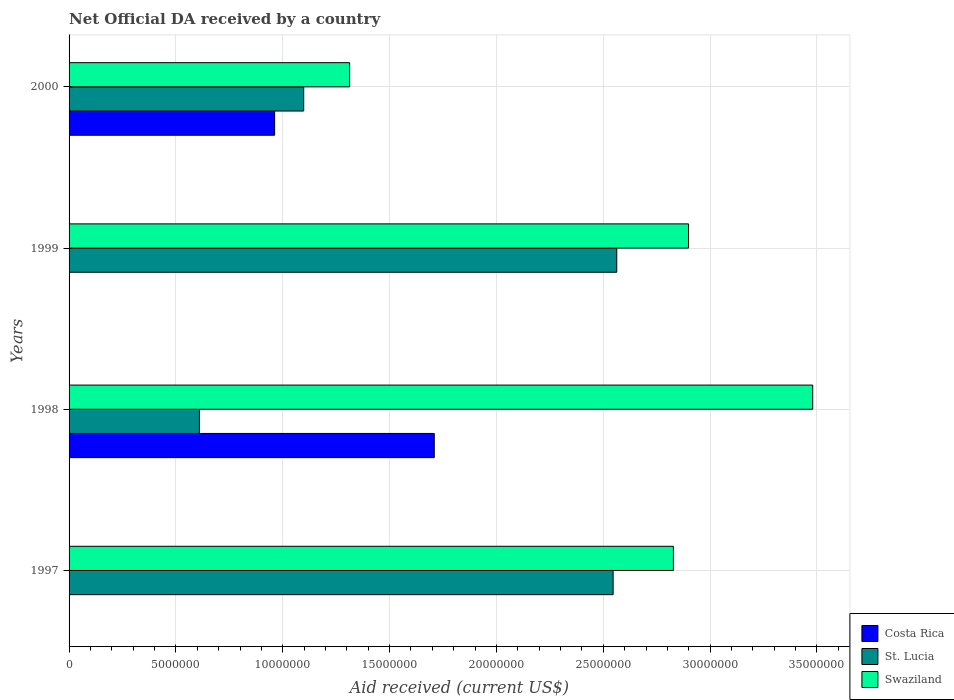How many different coloured bars are there?
Your answer should be compact. 3. How many groups of bars are there?
Your answer should be very brief. 4. Are the number of bars per tick equal to the number of legend labels?
Your response must be concise. No. How many bars are there on the 3rd tick from the top?
Keep it short and to the point. 3. What is the net official development assistance aid received in Costa Rica in 2000?
Your answer should be compact. 9.62e+06. Across all years, what is the maximum net official development assistance aid received in Costa Rica?
Your response must be concise. 1.71e+07. Across all years, what is the minimum net official development assistance aid received in St. Lucia?
Your answer should be very brief. 6.10e+06. What is the total net official development assistance aid received in St. Lucia in the graph?
Provide a succinct answer. 6.82e+07. What is the difference between the net official development assistance aid received in St. Lucia in 1997 and that in 2000?
Your answer should be very brief. 1.45e+07. What is the difference between the net official development assistance aid received in Swaziland in 2000 and the net official development assistance aid received in St. Lucia in 1997?
Provide a succinct answer. -1.23e+07. What is the average net official development assistance aid received in St. Lucia per year?
Your answer should be very brief. 1.70e+07. In the year 2000, what is the difference between the net official development assistance aid received in Swaziland and net official development assistance aid received in Costa Rica?
Offer a terse response. 3.51e+06. What is the ratio of the net official development assistance aid received in Swaziland in 1998 to that in 1999?
Ensure brevity in your answer.  1.2. What is the difference between the highest and the second highest net official development assistance aid received in Swaziland?
Your answer should be very brief. 5.81e+06. What is the difference between the highest and the lowest net official development assistance aid received in St. Lucia?
Make the answer very short. 1.95e+07. In how many years, is the net official development assistance aid received in Swaziland greater than the average net official development assistance aid received in Swaziland taken over all years?
Make the answer very short. 3. How many years are there in the graph?
Keep it short and to the point. 4. Are the values on the major ticks of X-axis written in scientific E-notation?
Keep it short and to the point. No. Does the graph contain any zero values?
Give a very brief answer. Yes. What is the title of the graph?
Provide a succinct answer. Net Official DA received by a country. What is the label or title of the X-axis?
Offer a very short reply. Aid received (current US$). What is the Aid received (current US$) of Costa Rica in 1997?
Your answer should be very brief. 0. What is the Aid received (current US$) of St. Lucia in 1997?
Your answer should be compact. 2.55e+07. What is the Aid received (current US$) of Swaziland in 1997?
Offer a very short reply. 2.83e+07. What is the Aid received (current US$) of Costa Rica in 1998?
Offer a terse response. 1.71e+07. What is the Aid received (current US$) in St. Lucia in 1998?
Provide a succinct answer. 6.10e+06. What is the Aid received (current US$) of Swaziland in 1998?
Keep it short and to the point. 3.48e+07. What is the Aid received (current US$) in Costa Rica in 1999?
Ensure brevity in your answer.  0. What is the Aid received (current US$) of St. Lucia in 1999?
Provide a succinct answer. 2.56e+07. What is the Aid received (current US$) of Swaziland in 1999?
Keep it short and to the point. 2.90e+07. What is the Aid received (current US$) of Costa Rica in 2000?
Offer a very short reply. 9.62e+06. What is the Aid received (current US$) of St. Lucia in 2000?
Provide a short and direct response. 1.10e+07. What is the Aid received (current US$) in Swaziland in 2000?
Provide a succinct answer. 1.31e+07. Across all years, what is the maximum Aid received (current US$) in Costa Rica?
Keep it short and to the point. 1.71e+07. Across all years, what is the maximum Aid received (current US$) of St. Lucia?
Your response must be concise. 2.56e+07. Across all years, what is the maximum Aid received (current US$) of Swaziland?
Ensure brevity in your answer.  3.48e+07. Across all years, what is the minimum Aid received (current US$) in St. Lucia?
Your answer should be compact. 6.10e+06. Across all years, what is the minimum Aid received (current US$) of Swaziland?
Offer a terse response. 1.31e+07. What is the total Aid received (current US$) of Costa Rica in the graph?
Offer a terse response. 2.67e+07. What is the total Aid received (current US$) of St. Lucia in the graph?
Provide a short and direct response. 6.82e+07. What is the total Aid received (current US$) of Swaziland in the graph?
Offer a terse response. 1.05e+08. What is the difference between the Aid received (current US$) in St. Lucia in 1997 and that in 1998?
Offer a very short reply. 1.94e+07. What is the difference between the Aid received (current US$) of Swaziland in 1997 and that in 1998?
Your answer should be compact. -6.52e+06. What is the difference between the Aid received (current US$) in St. Lucia in 1997 and that in 1999?
Give a very brief answer. -1.70e+05. What is the difference between the Aid received (current US$) of Swaziland in 1997 and that in 1999?
Provide a succinct answer. -7.10e+05. What is the difference between the Aid received (current US$) in St. Lucia in 1997 and that in 2000?
Offer a very short reply. 1.45e+07. What is the difference between the Aid received (current US$) of Swaziland in 1997 and that in 2000?
Make the answer very short. 1.52e+07. What is the difference between the Aid received (current US$) in St. Lucia in 1998 and that in 1999?
Provide a short and direct response. -1.95e+07. What is the difference between the Aid received (current US$) of Swaziland in 1998 and that in 1999?
Your answer should be compact. 5.81e+06. What is the difference between the Aid received (current US$) in Costa Rica in 1998 and that in 2000?
Keep it short and to the point. 7.47e+06. What is the difference between the Aid received (current US$) of St. Lucia in 1998 and that in 2000?
Offer a terse response. -4.88e+06. What is the difference between the Aid received (current US$) in Swaziland in 1998 and that in 2000?
Give a very brief answer. 2.17e+07. What is the difference between the Aid received (current US$) in St. Lucia in 1999 and that in 2000?
Offer a very short reply. 1.46e+07. What is the difference between the Aid received (current US$) in Swaziland in 1999 and that in 2000?
Provide a short and direct response. 1.59e+07. What is the difference between the Aid received (current US$) of St. Lucia in 1997 and the Aid received (current US$) of Swaziland in 1998?
Give a very brief answer. -9.34e+06. What is the difference between the Aid received (current US$) of St. Lucia in 1997 and the Aid received (current US$) of Swaziland in 1999?
Keep it short and to the point. -3.53e+06. What is the difference between the Aid received (current US$) in St. Lucia in 1997 and the Aid received (current US$) in Swaziland in 2000?
Offer a very short reply. 1.23e+07. What is the difference between the Aid received (current US$) of Costa Rica in 1998 and the Aid received (current US$) of St. Lucia in 1999?
Offer a terse response. -8.54e+06. What is the difference between the Aid received (current US$) of Costa Rica in 1998 and the Aid received (current US$) of Swaziland in 1999?
Your response must be concise. -1.19e+07. What is the difference between the Aid received (current US$) in St. Lucia in 1998 and the Aid received (current US$) in Swaziland in 1999?
Keep it short and to the point. -2.29e+07. What is the difference between the Aid received (current US$) of Costa Rica in 1998 and the Aid received (current US$) of St. Lucia in 2000?
Your answer should be compact. 6.11e+06. What is the difference between the Aid received (current US$) in Costa Rica in 1998 and the Aid received (current US$) in Swaziland in 2000?
Your response must be concise. 3.96e+06. What is the difference between the Aid received (current US$) in St. Lucia in 1998 and the Aid received (current US$) in Swaziland in 2000?
Provide a succinct answer. -7.03e+06. What is the difference between the Aid received (current US$) of St. Lucia in 1999 and the Aid received (current US$) of Swaziland in 2000?
Provide a short and direct response. 1.25e+07. What is the average Aid received (current US$) of Costa Rica per year?
Provide a succinct answer. 6.68e+06. What is the average Aid received (current US$) in St. Lucia per year?
Give a very brief answer. 1.70e+07. What is the average Aid received (current US$) in Swaziland per year?
Make the answer very short. 2.63e+07. In the year 1997, what is the difference between the Aid received (current US$) of St. Lucia and Aid received (current US$) of Swaziland?
Offer a terse response. -2.82e+06. In the year 1998, what is the difference between the Aid received (current US$) of Costa Rica and Aid received (current US$) of St. Lucia?
Your response must be concise. 1.10e+07. In the year 1998, what is the difference between the Aid received (current US$) in Costa Rica and Aid received (current US$) in Swaziland?
Offer a very short reply. -1.77e+07. In the year 1998, what is the difference between the Aid received (current US$) in St. Lucia and Aid received (current US$) in Swaziland?
Your response must be concise. -2.87e+07. In the year 1999, what is the difference between the Aid received (current US$) in St. Lucia and Aid received (current US$) in Swaziland?
Make the answer very short. -3.36e+06. In the year 2000, what is the difference between the Aid received (current US$) of Costa Rica and Aid received (current US$) of St. Lucia?
Ensure brevity in your answer.  -1.36e+06. In the year 2000, what is the difference between the Aid received (current US$) in Costa Rica and Aid received (current US$) in Swaziland?
Keep it short and to the point. -3.51e+06. In the year 2000, what is the difference between the Aid received (current US$) in St. Lucia and Aid received (current US$) in Swaziland?
Offer a terse response. -2.15e+06. What is the ratio of the Aid received (current US$) in St. Lucia in 1997 to that in 1998?
Make the answer very short. 4.17. What is the ratio of the Aid received (current US$) in Swaziland in 1997 to that in 1998?
Offer a terse response. 0.81. What is the ratio of the Aid received (current US$) in St. Lucia in 1997 to that in 1999?
Make the answer very short. 0.99. What is the ratio of the Aid received (current US$) of Swaziland in 1997 to that in 1999?
Offer a terse response. 0.98. What is the ratio of the Aid received (current US$) in St. Lucia in 1997 to that in 2000?
Provide a succinct answer. 2.32. What is the ratio of the Aid received (current US$) in Swaziland in 1997 to that in 2000?
Your answer should be compact. 2.15. What is the ratio of the Aid received (current US$) of St. Lucia in 1998 to that in 1999?
Provide a succinct answer. 0.24. What is the ratio of the Aid received (current US$) in Swaziland in 1998 to that in 1999?
Your answer should be compact. 1.2. What is the ratio of the Aid received (current US$) in Costa Rica in 1998 to that in 2000?
Your response must be concise. 1.78. What is the ratio of the Aid received (current US$) in St. Lucia in 1998 to that in 2000?
Keep it short and to the point. 0.56. What is the ratio of the Aid received (current US$) of Swaziland in 1998 to that in 2000?
Give a very brief answer. 2.65. What is the ratio of the Aid received (current US$) in St. Lucia in 1999 to that in 2000?
Give a very brief answer. 2.33. What is the ratio of the Aid received (current US$) of Swaziland in 1999 to that in 2000?
Make the answer very short. 2.21. What is the difference between the highest and the second highest Aid received (current US$) in Swaziland?
Make the answer very short. 5.81e+06. What is the difference between the highest and the lowest Aid received (current US$) of Costa Rica?
Your answer should be very brief. 1.71e+07. What is the difference between the highest and the lowest Aid received (current US$) of St. Lucia?
Provide a short and direct response. 1.95e+07. What is the difference between the highest and the lowest Aid received (current US$) in Swaziland?
Offer a terse response. 2.17e+07. 